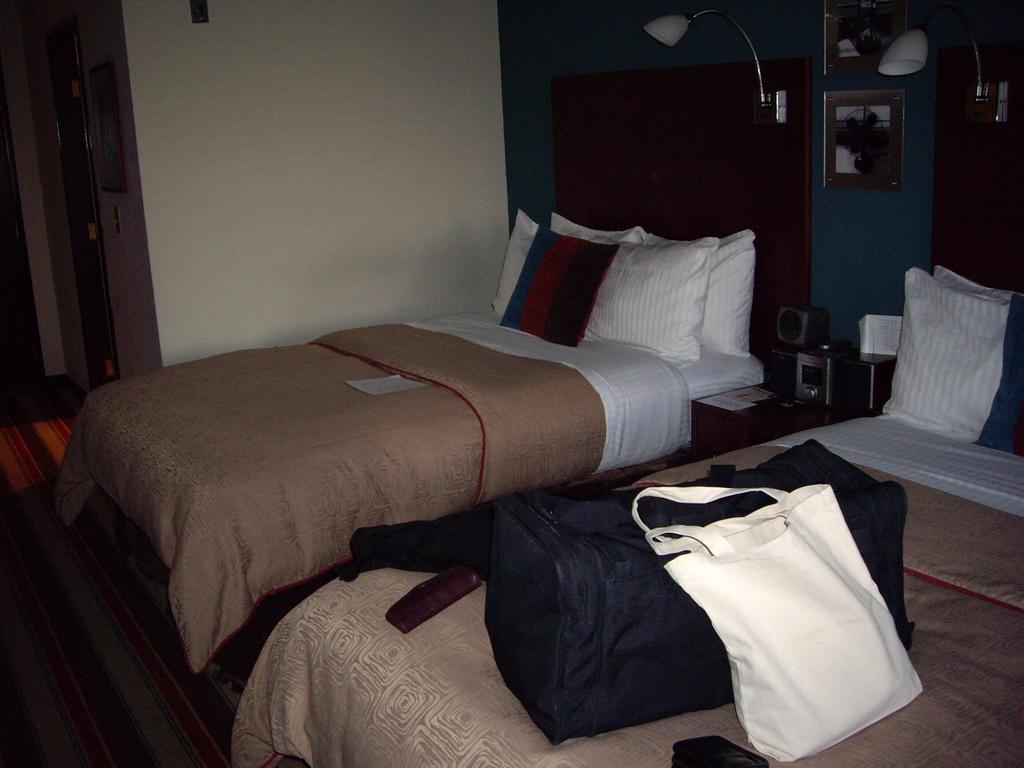Can you describe this image briefly? This picture shows two beds and two bags on the bed and we see couple of pillows on both the beds and we see a mirror and a light and we see a paper on the bed 